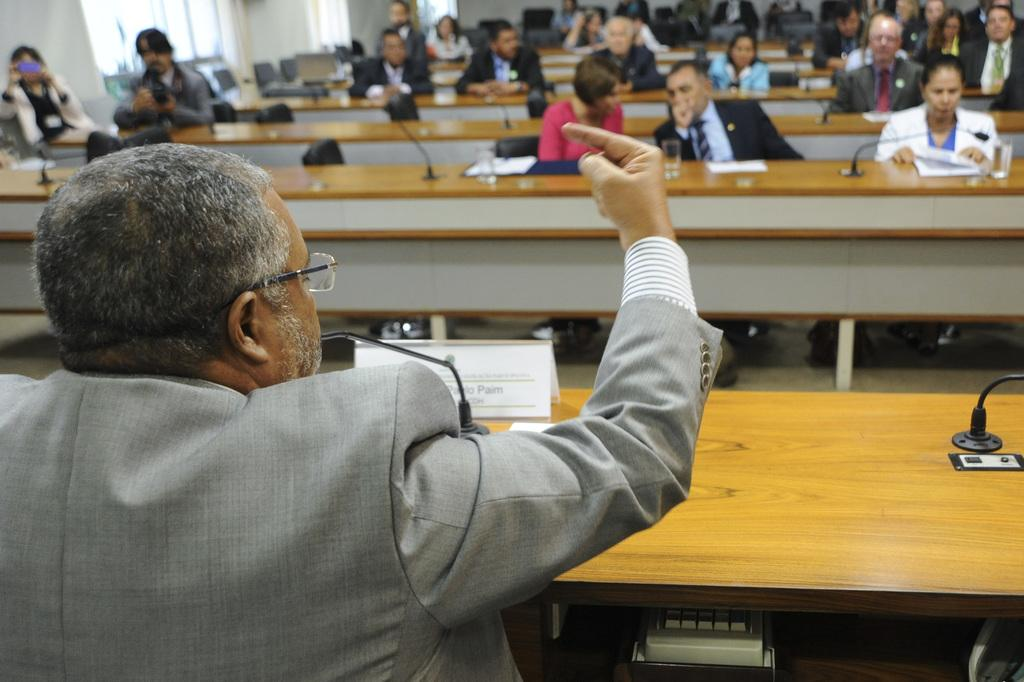Who is the main subject in the image? There is a man in the image. What are the people in front of the man doing? The people are sitting in front of the man. How are the people arranged in the image? The people are sitting on chairs at tables. What might the people be doing while sitting at the tables? The people are listening to the man. What objects can be seen on the tables in the image? There are microphones, books, and glasses of water on the tables. What type of tin can be seen in the image? There is no tin present in the image. 